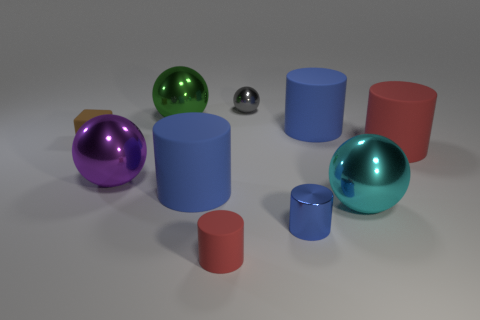Subtract all big balls. How many balls are left? 1 Subtract all blue cylinders. How many cylinders are left? 2 Subtract 1 cylinders. How many cylinders are left? 4 Subtract all blocks. How many objects are left? 9 Subtract all brown things. Subtract all small brown matte cubes. How many objects are left? 8 Add 9 large cyan metallic objects. How many large cyan metallic objects are left? 10 Add 5 brown rubber things. How many brown rubber things exist? 6 Subtract 0 red balls. How many objects are left? 10 Subtract all gray cylinders. Subtract all green blocks. How many cylinders are left? 5 Subtract all purple cylinders. How many gray blocks are left? 0 